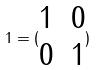Convert formula to latex. <formula><loc_0><loc_0><loc_500><loc_500>1 = ( \begin{matrix} 1 & 0 \\ 0 & 1 \end{matrix} )</formula> 